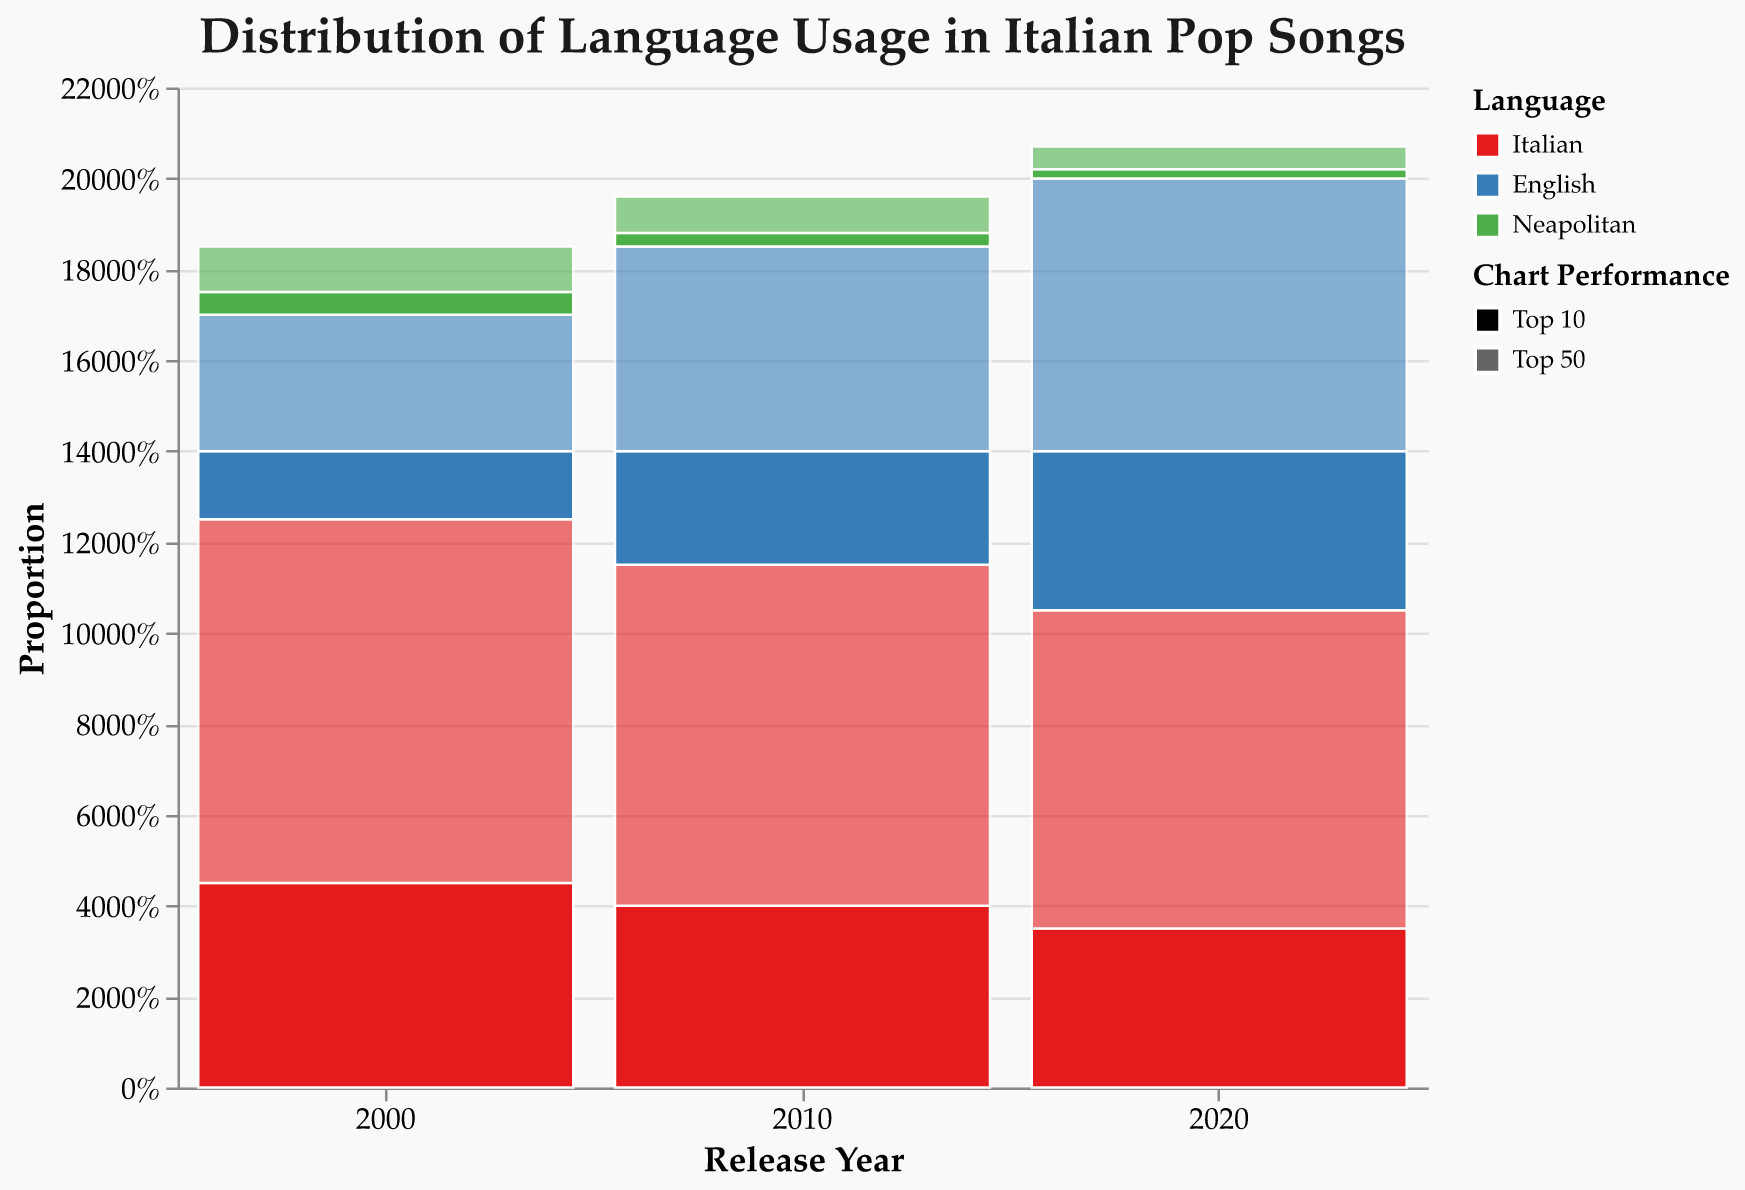What's the title of the figure? The title is located at the top of the figure and is meant to describe what the graphic represents. In this case, the title is "Distribution of Language Usage in Italian Pop Songs".
Answer: Distribution of Language Usage in Italian Pop Songs What languages are represented in the mosaic plot? The colors in the legend indicate the languages. The plot includes three languages: Italian, English, and Neapolitan.
Answer: Italian, English, Neapolitan How did the proportion of Italian songs in the Top 10 change from 2000 to 2020? By observing the height of the bars for Italian songs in the Top 10 category across the years, we see that the proportion slightly decreases from a higher level in 2000 to a relatively lower level in 2020.
Answer: Decreased In 2020, which language had the highest proportion of Top 10 chart performance? By comparing the heights of the bars for each language in the Top 10 category for the year 2020, English songs have the highest bar, indicating the highest proportion.
Answer: English What is the color used to represent Neapolitan songs? The legend shows the colors representing each language. Neapolitan songs are represented by a green color.
Answer: Green How many operations are used to calculate the percentage in the data transformation? To determine the percentage, we first sum the counts for each group, stack them to find y0 and y1, find the height by subtracting y0 from y1, and finally calculate the percentage by dividing the sum count by the total for the year. Four main operations are used in this process.
Answer: Four operations Compare the proportion of English songs in the Top 50 category between 2000 and 2020. Which year had a higher proportion? By looking at the height of the bars for English songs in the Top 50 category, the proportion is higher in 2020 compared to 2000.
Answer: 2020 What trend can be observed for Neapolitan songs in the Top 50 category over the years? Observing the bars for Neapolitan songs in the Top 50 category, we notice a consistent decrease in proportion from 2000 to 2020.
Answer: Decreasing trend Which year had the highest proportion of Italian songs overall (Top 10 and Top 50 combined)? Adding the heights of the bars for Italian songs in both Top 10 and Top 50 categories for each year, it appears that the year 2000 had the highest combined proportion.
Answer: 2000 